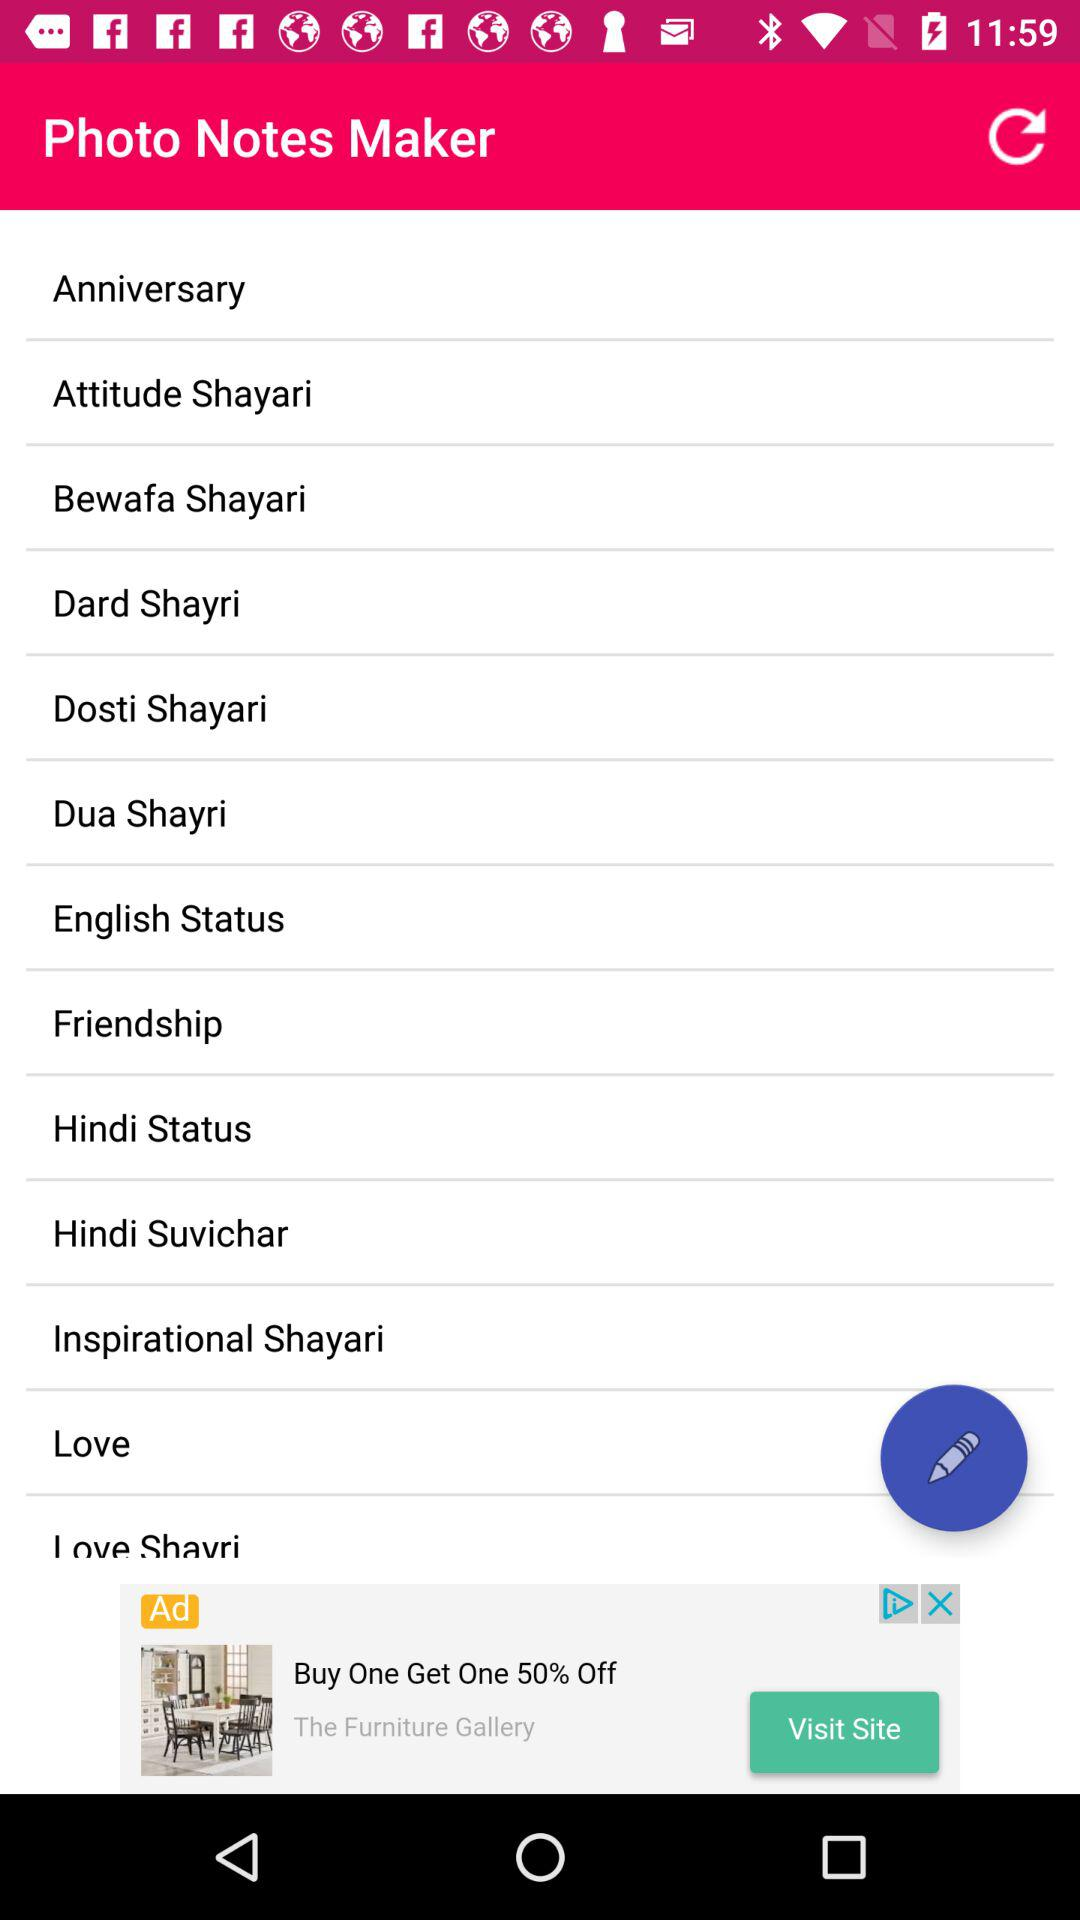What is the name of the application? The name of the application is "Photo Notes Maker". 